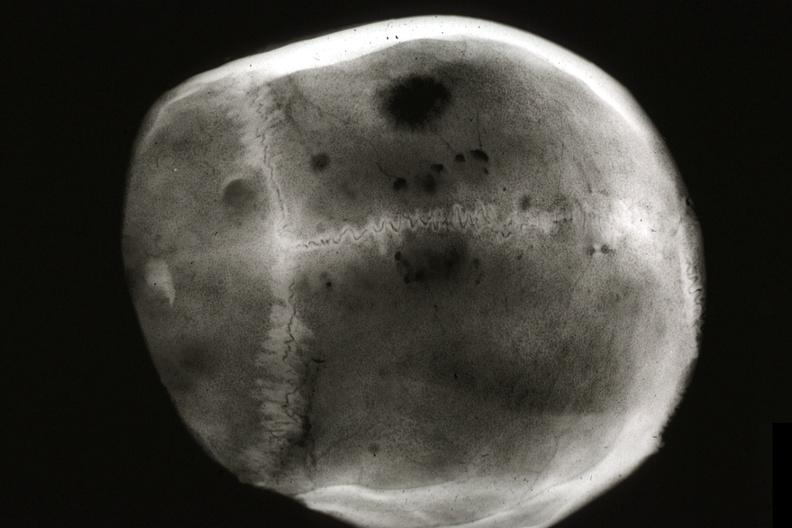s siamese twins present?
Answer the question using a single word or phrase. No 